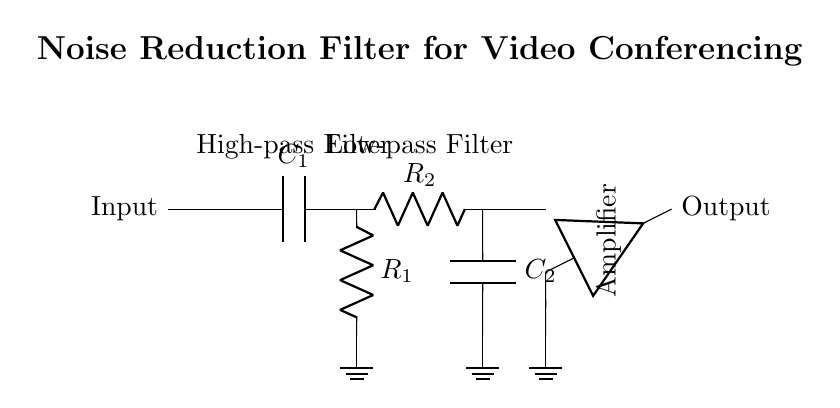What type of filter is shown in this circuit? The circuit diagram describes a noise reduction filter, which combines both high-pass and low-pass filtering techniques to attenuate unwanted frequencies while allowing signal frequencies relevant for video conferencing to pass through.
Answer: noise reduction filter How many capacitors are in this circuit? Upon examining the circuit diagram, two capacitors labeled C1 and C2 are identified. Each capacitor serves a different function, with one used in the high-pass filter and the other in the low-pass filter.
Answer: two Which components are used in the high-pass filter? In the high-pass filter section of the circuit, it can be seen that there is a capacitor (C1) connected in series with a resistor (R1), where the resistor is connected to ground, allowing high-frequency signals to pass while blocking lower frequencies.
Answer: capacitor and resistor What is the purpose of the amplifier in this circuit? The amplifier is placed at the output of the filter circuit, allowing the overall signal to be increased in amplitude after passing through the filters. This is crucial for ensuring that the output signal level is sufficient for video conferencing applications.
Answer: increase signal amplitude What is the resistance value of R2 in the low-pass filter? The circuit diagram identifies the resistor in the low-pass filter section as R2, however, no specific numerical value is given in the diagram itself, suggesting that its resistance could be selected based on design criteria for the application.
Answer: not specified Which component connects the two filter sections? The short connection at point 3 in the circuit diagram serves as the junction between the high-pass and low-pass filter sections. This connection permits the signals processed by each filter to be combined before reaching the amplifier.
Answer: short connection What frequency range does the noise reduction filter allow? The combination of the high-pass and low-pass filters will permit a specific range of frequencies to pass through while attenuating noise outside this range, enabling the circuit to effectively enhance video conferencing clarity by filtering out unwanted frequencies.
Answer: specific range of frequencies 